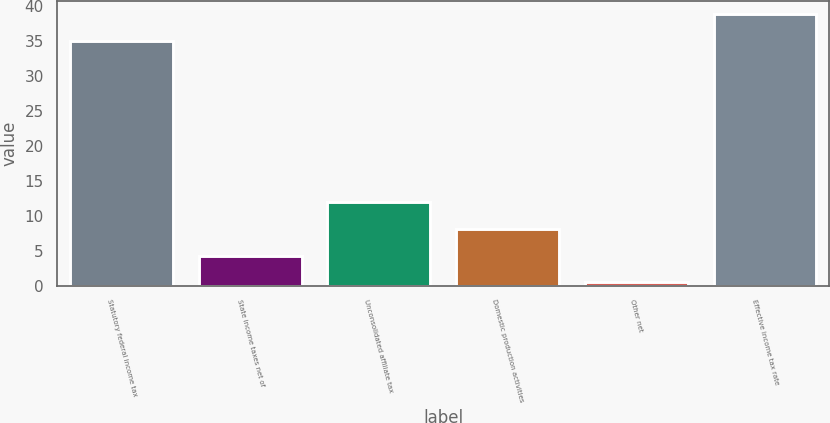Convert chart. <chart><loc_0><loc_0><loc_500><loc_500><bar_chart><fcel>Statutory federal income tax<fcel>State income taxes net of<fcel>Unconsolidated affiliate tax<fcel>Domestic production activities<fcel>Other net<fcel>Effective income tax rate<nl><fcel>35<fcel>4.31<fcel>11.93<fcel>8.12<fcel>0.5<fcel>38.81<nl></chart> 